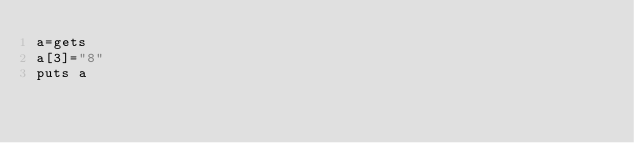<code> <loc_0><loc_0><loc_500><loc_500><_Ruby_>a=gets
a[3]="8"
puts a</code> 